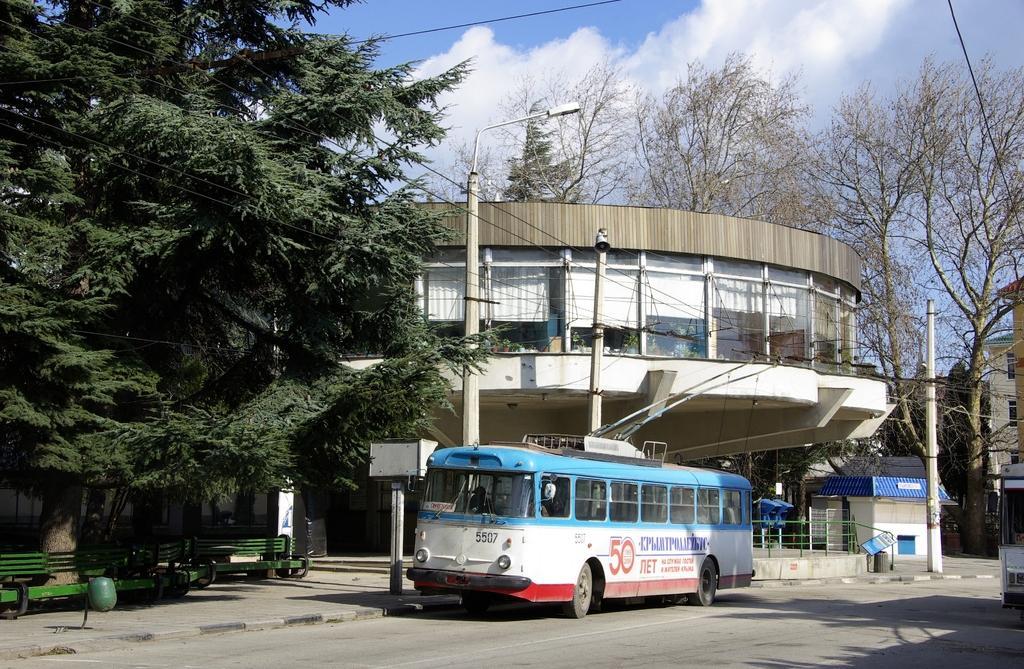How would you summarize this image in a sentence or two? In the image there is a bus moving on road, behind it there is a building with trees on either side of it, on the left side there are benches on the foot path, on the right side there is a electric pole and above its sky with clouds. 